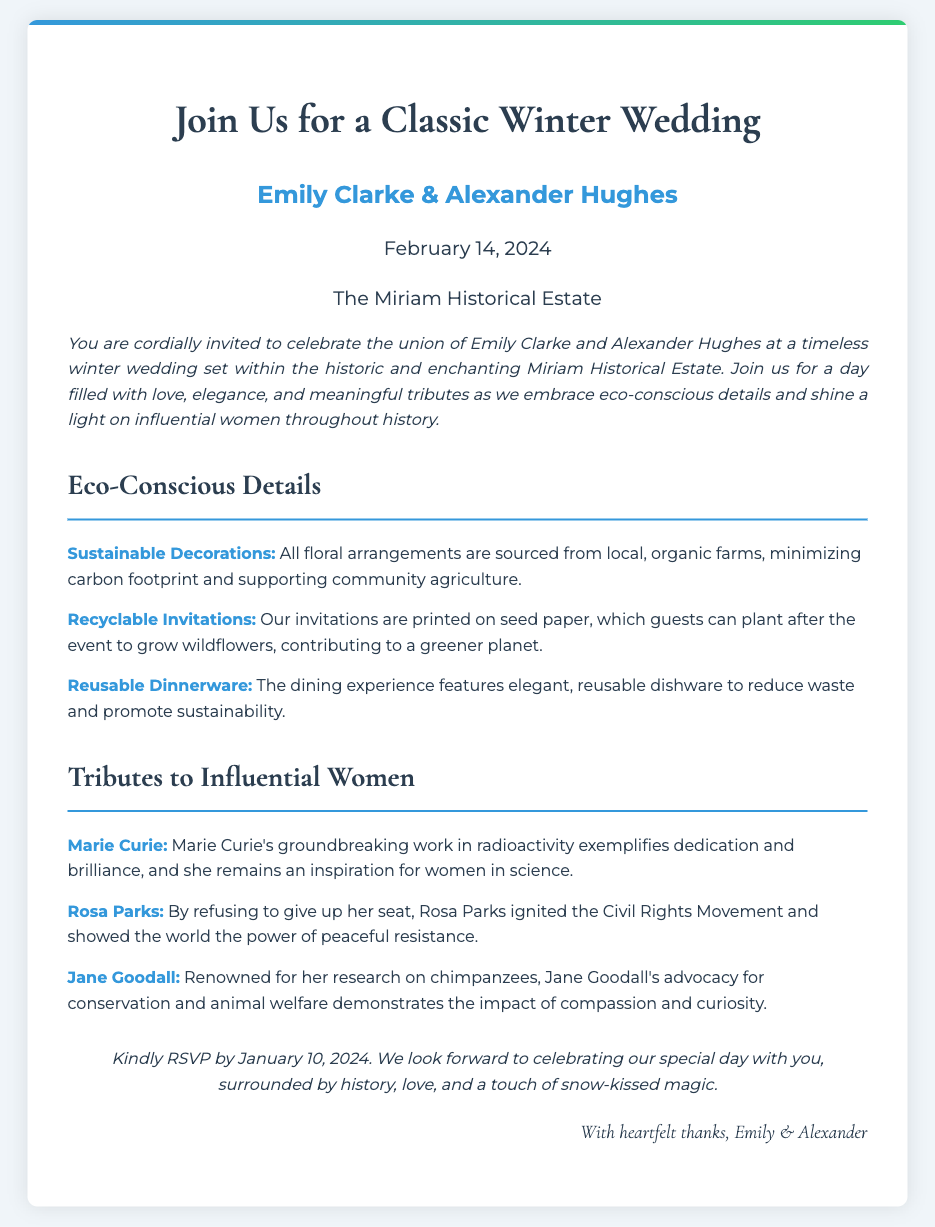what is the name of the bride? The bride's name is mentioned in the invitation as Emily Clarke.
Answer: Emily Clarke what date is the wedding? The wedding date is specified clearly in the document as February 14, 2024.
Answer: February 14, 2024 where is the wedding venue? The venue for the wedding is the Miriam Historical Estate.
Answer: The Miriam Historical Estate which influential woman is known for her work in radioactivity? The document notes that Marie Curie is recognized for her groundbreaking work in radioactivity.
Answer: Marie Curie what type of invitations are used? The invitation states that the invitations are printed on seed paper.
Answer: Seed paper what is one of the sustainable decoration sources? It is mentioned that floral arrangements are sourced from local, organic farms to ensure sustainability.
Answer: Local, organic farms how should guests respond to the invitation? The invitation specifies that guests should kindly RSVP by January 10, 2024.
Answer: RSVP by January 10, 2024 what is the theme of the wedding? The theme of the wedding is indicated as a classic winter wedding.
Answer: Classic winter wedding who is the groom? The groom's name is mentioned in the invitation as Alexander Hughes.
Answer: Alexander Hughes 